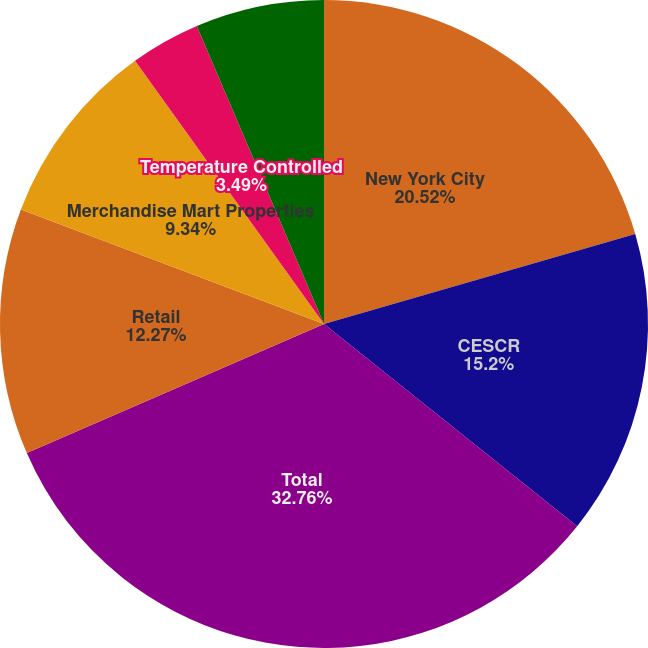Convert chart. <chart><loc_0><loc_0><loc_500><loc_500><pie_chart><fcel>New York City<fcel>CESCR<fcel>Total<fcel>Retail<fcel>Merchandise Mart Properties<fcel>Temperature Controlled<fcel>Other<nl><fcel>20.52%<fcel>15.2%<fcel>32.75%<fcel>12.27%<fcel>9.34%<fcel>3.49%<fcel>6.42%<nl></chart> 